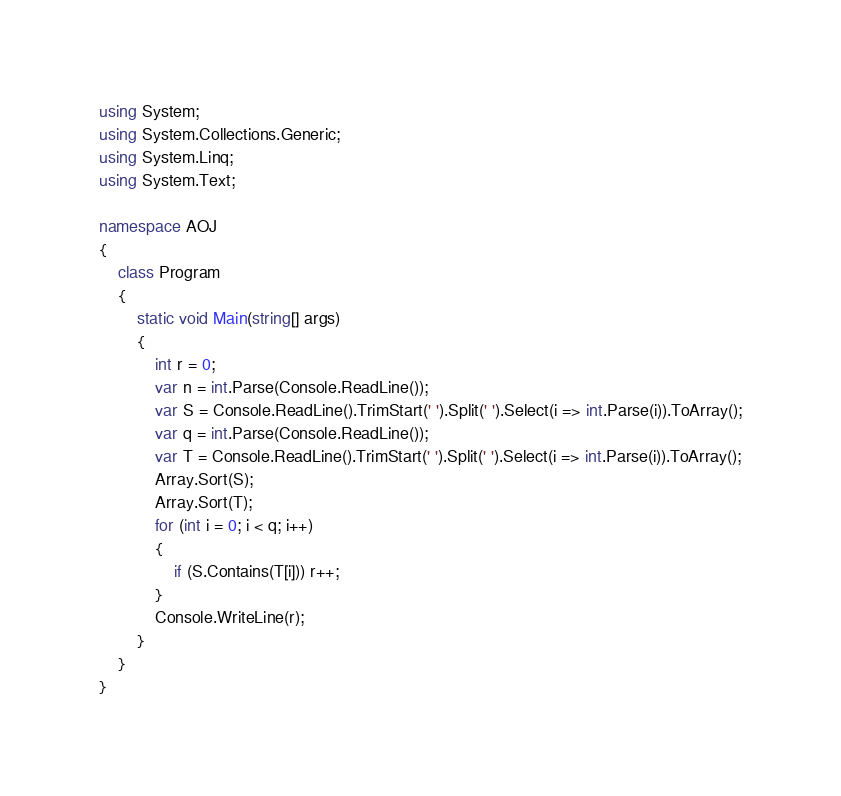<code> <loc_0><loc_0><loc_500><loc_500><_C#_>using System;
using System.Collections.Generic;
using System.Linq;
using System.Text;

namespace AOJ
{
	class Program
	{
		static void Main(string[] args)
		{
			int r = 0;
			var n = int.Parse(Console.ReadLine());
			var S = Console.ReadLine().TrimStart(' ').Split(' ').Select(i => int.Parse(i)).ToArray();
			var q = int.Parse(Console.ReadLine());
			var T = Console.ReadLine().TrimStart(' ').Split(' ').Select(i => int.Parse(i)).ToArray();
			Array.Sort(S);
			Array.Sort(T);
			for (int i = 0; i < q; i++)
			{
				if (S.Contains(T[i])) r++;
			}
			Console.WriteLine(r);
		}
	}
}</code> 